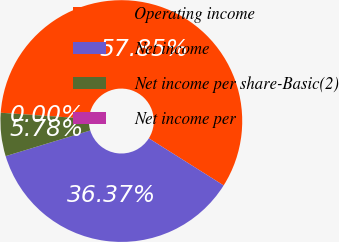Convert chart to OTSL. <chart><loc_0><loc_0><loc_500><loc_500><pie_chart><fcel>Operating income<fcel>Net income<fcel>Net income per share-Basic(2)<fcel>Net income per<nl><fcel>57.84%<fcel>36.37%<fcel>5.78%<fcel>0.0%<nl></chart> 